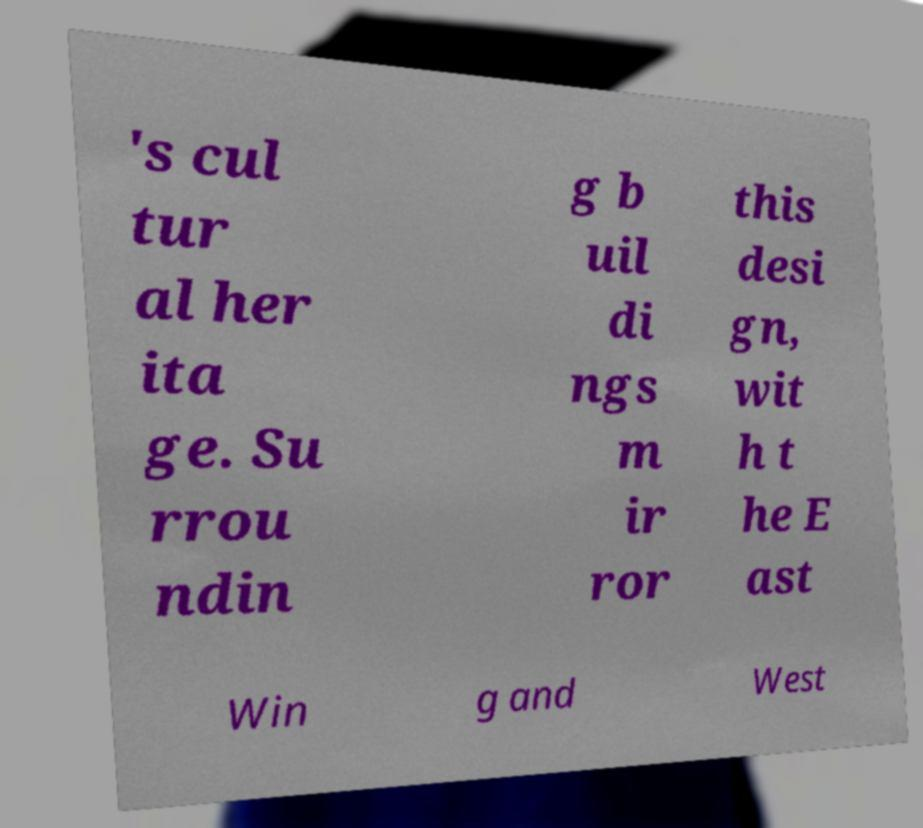Could you extract and type out the text from this image? 's cul tur al her ita ge. Su rrou ndin g b uil di ngs m ir ror this desi gn, wit h t he E ast Win g and West 